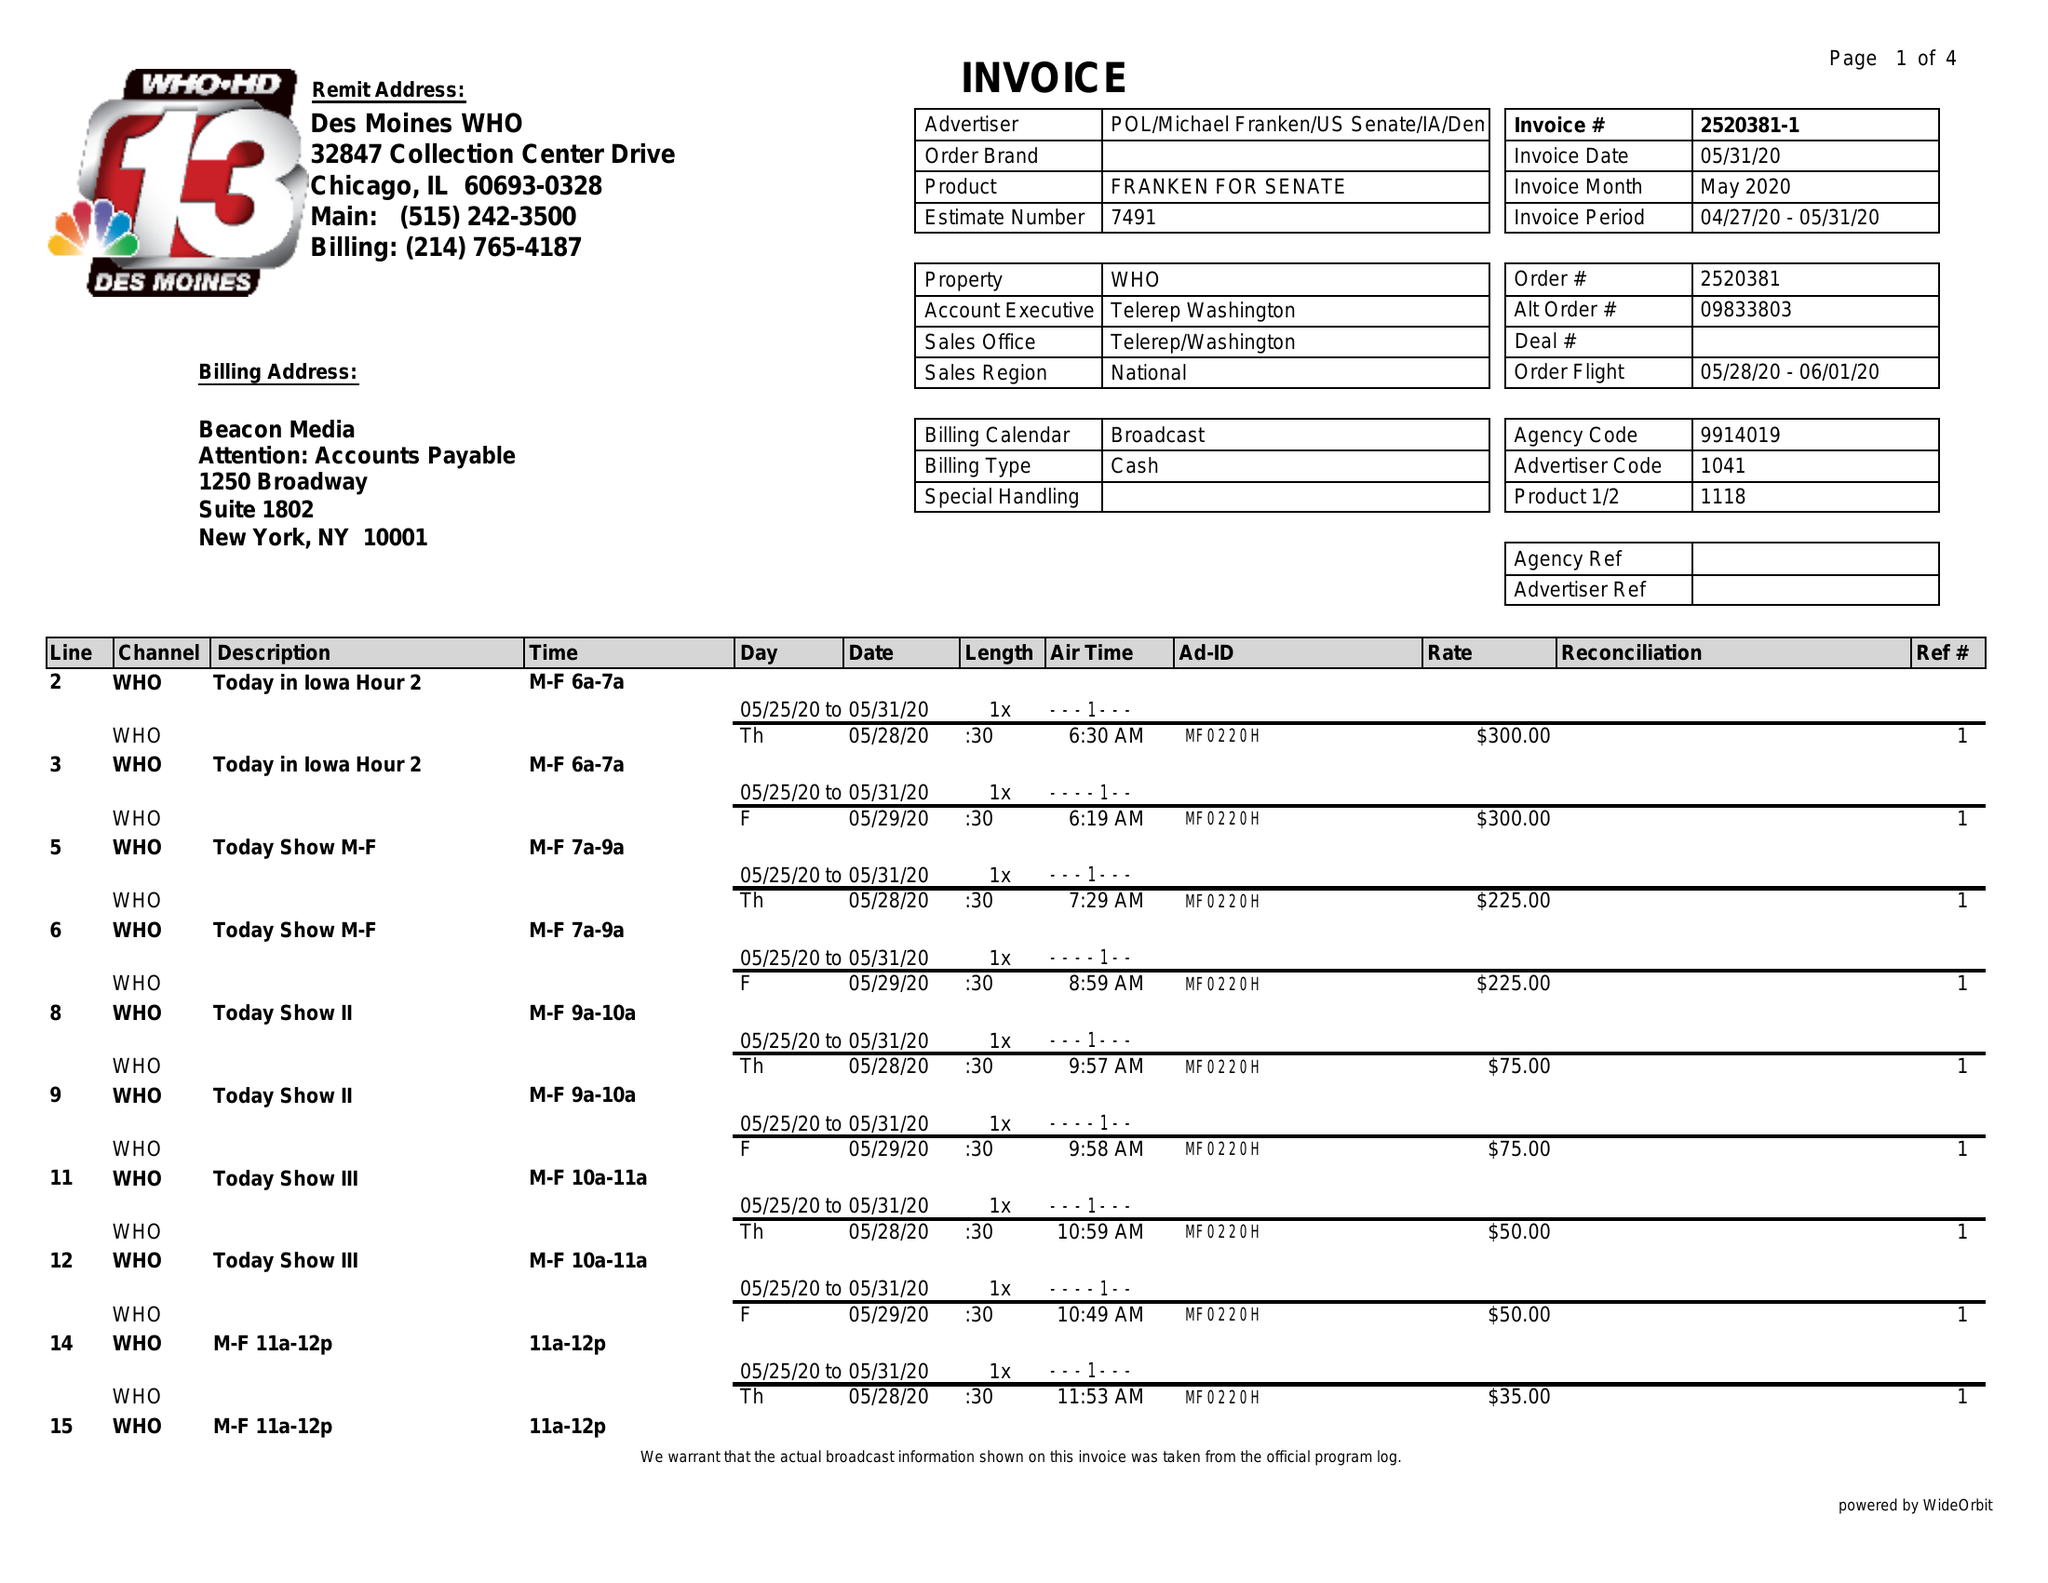What is the value for the flight_to?
Answer the question using a single word or phrase. 06/01/20 